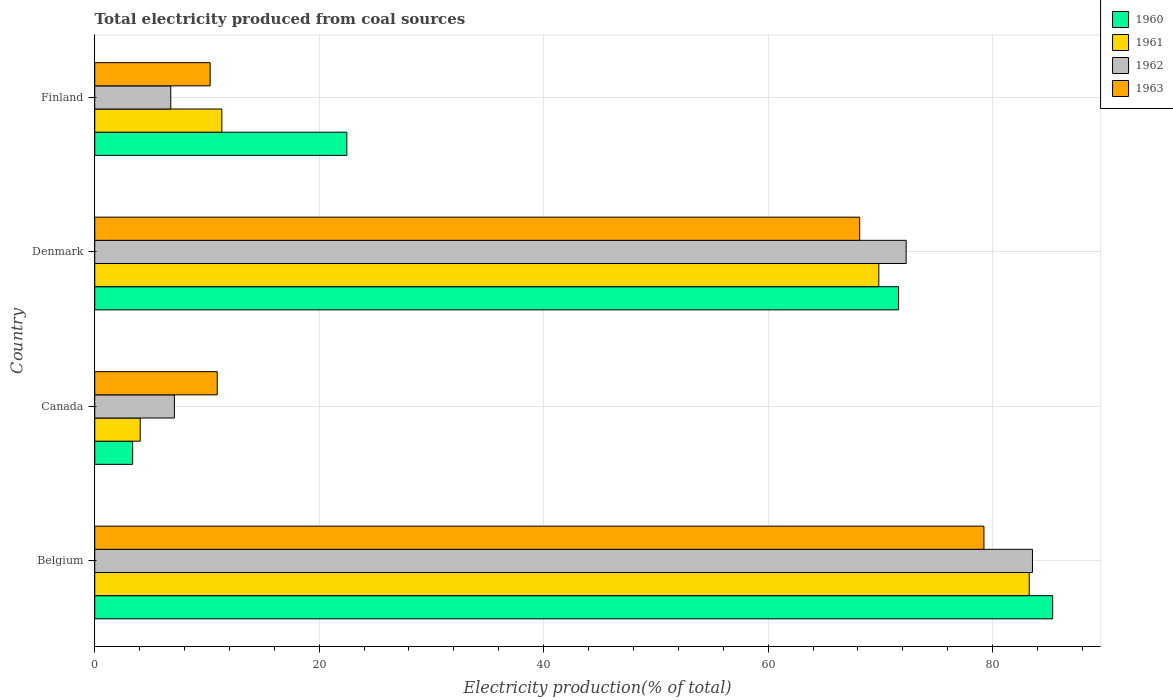How many different coloured bars are there?
Provide a short and direct response. 4. Are the number of bars per tick equal to the number of legend labels?
Make the answer very short. Yes. Are the number of bars on each tick of the Y-axis equal?
Keep it short and to the point. Yes. How many bars are there on the 4th tick from the top?
Provide a succinct answer. 4. In how many cases, is the number of bars for a given country not equal to the number of legend labels?
Give a very brief answer. 0. What is the total electricity produced in 1962 in Finland?
Provide a succinct answer. 6.78. Across all countries, what is the maximum total electricity produced in 1962?
Make the answer very short. 83.56. Across all countries, what is the minimum total electricity produced in 1963?
Provide a succinct answer. 10.28. In which country was the total electricity produced in 1962 minimum?
Your answer should be very brief. Finland. What is the total total electricity produced in 1961 in the graph?
Make the answer very short. 168.51. What is the difference between the total electricity produced in 1961 in Belgium and that in Canada?
Offer a terse response. 79.21. What is the difference between the total electricity produced in 1961 in Denmark and the total electricity produced in 1963 in Finland?
Offer a very short reply. 59.58. What is the average total electricity produced in 1963 per country?
Offer a very short reply. 42.15. What is the difference between the total electricity produced in 1961 and total electricity produced in 1960 in Belgium?
Provide a short and direct response. -2.09. What is the ratio of the total electricity produced in 1962 in Canada to that in Finland?
Provide a succinct answer. 1.05. Is the total electricity produced in 1961 in Belgium less than that in Finland?
Offer a terse response. No. Is the difference between the total electricity produced in 1961 in Belgium and Canada greater than the difference between the total electricity produced in 1960 in Belgium and Canada?
Make the answer very short. No. What is the difference between the highest and the second highest total electricity produced in 1962?
Your response must be concise. 11.26. What is the difference between the highest and the lowest total electricity produced in 1961?
Provide a succinct answer. 79.21. In how many countries, is the total electricity produced in 1960 greater than the average total electricity produced in 1960 taken over all countries?
Make the answer very short. 2. Is the sum of the total electricity produced in 1960 in Belgium and Canada greater than the maximum total electricity produced in 1961 across all countries?
Offer a terse response. Yes. Is it the case that in every country, the sum of the total electricity produced in 1962 and total electricity produced in 1960 is greater than the sum of total electricity produced in 1963 and total electricity produced in 1961?
Your response must be concise. No. What does the 3rd bar from the top in Belgium represents?
Provide a short and direct response. 1961. Are all the bars in the graph horizontal?
Your answer should be compact. Yes. How many countries are there in the graph?
Provide a short and direct response. 4. Are the values on the major ticks of X-axis written in scientific E-notation?
Provide a short and direct response. No. Does the graph contain any zero values?
Give a very brief answer. No. Does the graph contain grids?
Provide a short and direct response. Yes. Where does the legend appear in the graph?
Your answer should be very brief. Top right. How many legend labels are there?
Offer a terse response. 4. How are the legend labels stacked?
Provide a succinct answer. Vertical. What is the title of the graph?
Offer a terse response. Total electricity produced from coal sources. Does "2009" appear as one of the legend labels in the graph?
Offer a terse response. No. What is the label or title of the X-axis?
Make the answer very short. Electricity production(% of total). What is the label or title of the Y-axis?
Provide a succinct answer. Country. What is the Electricity production(% of total) in 1960 in Belgium?
Your answer should be very brief. 85.36. What is the Electricity production(% of total) in 1961 in Belgium?
Keep it short and to the point. 83.27. What is the Electricity production(% of total) of 1962 in Belgium?
Provide a succinct answer. 83.56. What is the Electricity production(% of total) of 1963 in Belgium?
Provide a short and direct response. 79.23. What is the Electricity production(% of total) of 1960 in Canada?
Offer a terse response. 3.38. What is the Electricity production(% of total) of 1961 in Canada?
Provide a short and direct response. 4.05. What is the Electricity production(% of total) of 1962 in Canada?
Provide a short and direct response. 7.1. What is the Electricity production(% of total) of 1963 in Canada?
Ensure brevity in your answer.  10.92. What is the Electricity production(% of total) in 1960 in Denmark?
Make the answer very short. 71.62. What is the Electricity production(% of total) in 1961 in Denmark?
Your answer should be compact. 69.86. What is the Electricity production(% of total) of 1962 in Denmark?
Offer a terse response. 72.3. What is the Electricity production(% of total) in 1963 in Denmark?
Keep it short and to the point. 68.16. What is the Electricity production(% of total) in 1960 in Finland?
Make the answer very short. 22.46. What is the Electricity production(% of total) in 1961 in Finland?
Your response must be concise. 11.33. What is the Electricity production(% of total) of 1962 in Finland?
Your answer should be very brief. 6.78. What is the Electricity production(% of total) in 1963 in Finland?
Provide a short and direct response. 10.28. Across all countries, what is the maximum Electricity production(% of total) of 1960?
Your answer should be compact. 85.36. Across all countries, what is the maximum Electricity production(% of total) of 1961?
Give a very brief answer. 83.27. Across all countries, what is the maximum Electricity production(% of total) of 1962?
Provide a succinct answer. 83.56. Across all countries, what is the maximum Electricity production(% of total) of 1963?
Your answer should be compact. 79.23. Across all countries, what is the minimum Electricity production(% of total) of 1960?
Your response must be concise. 3.38. Across all countries, what is the minimum Electricity production(% of total) of 1961?
Ensure brevity in your answer.  4.05. Across all countries, what is the minimum Electricity production(% of total) of 1962?
Your response must be concise. 6.78. Across all countries, what is the minimum Electricity production(% of total) of 1963?
Provide a succinct answer. 10.28. What is the total Electricity production(% of total) of 1960 in the graph?
Ensure brevity in your answer.  182.82. What is the total Electricity production(% of total) of 1961 in the graph?
Provide a short and direct response. 168.51. What is the total Electricity production(% of total) of 1962 in the graph?
Offer a terse response. 169.73. What is the total Electricity production(% of total) in 1963 in the graph?
Provide a short and direct response. 168.59. What is the difference between the Electricity production(% of total) of 1960 in Belgium and that in Canada?
Make the answer very short. 81.98. What is the difference between the Electricity production(% of total) in 1961 in Belgium and that in Canada?
Your answer should be very brief. 79.21. What is the difference between the Electricity production(% of total) in 1962 in Belgium and that in Canada?
Make the answer very short. 76.46. What is the difference between the Electricity production(% of total) of 1963 in Belgium and that in Canada?
Make the answer very short. 68.31. What is the difference between the Electricity production(% of total) in 1960 in Belgium and that in Denmark?
Your answer should be very brief. 13.73. What is the difference between the Electricity production(% of total) in 1961 in Belgium and that in Denmark?
Your answer should be very brief. 13.4. What is the difference between the Electricity production(% of total) of 1962 in Belgium and that in Denmark?
Keep it short and to the point. 11.26. What is the difference between the Electricity production(% of total) in 1963 in Belgium and that in Denmark?
Your response must be concise. 11.07. What is the difference between the Electricity production(% of total) in 1960 in Belgium and that in Finland?
Provide a succinct answer. 62.89. What is the difference between the Electricity production(% of total) of 1961 in Belgium and that in Finland?
Offer a terse response. 71.94. What is the difference between the Electricity production(% of total) of 1962 in Belgium and that in Finland?
Your response must be concise. 76.78. What is the difference between the Electricity production(% of total) in 1963 in Belgium and that in Finland?
Give a very brief answer. 68.95. What is the difference between the Electricity production(% of total) in 1960 in Canada and that in Denmark?
Ensure brevity in your answer.  -68.25. What is the difference between the Electricity production(% of total) of 1961 in Canada and that in Denmark?
Your answer should be compact. -65.81. What is the difference between the Electricity production(% of total) in 1962 in Canada and that in Denmark?
Your response must be concise. -65.2. What is the difference between the Electricity production(% of total) of 1963 in Canada and that in Denmark?
Provide a short and direct response. -57.24. What is the difference between the Electricity production(% of total) of 1960 in Canada and that in Finland?
Make the answer very short. -19.09. What is the difference between the Electricity production(% of total) of 1961 in Canada and that in Finland?
Provide a succinct answer. -7.27. What is the difference between the Electricity production(% of total) in 1962 in Canada and that in Finland?
Provide a succinct answer. 0.32. What is the difference between the Electricity production(% of total) of 1963 in Canada and that in Finland?
Offer a very short reply. 0.63. What is the difference between the Electricity production(% of total) of 1960 in Denmark and that in Finland?
Provide a succinct answer. 49.16. What is the difference between the Electricity production(% of total) of 1961 in Denmark and that in Finland?
Provide a short and direct response. 58.54. What is the difference between the Electricity production(% of total) in 1962 in Denmark and that in Finland?
Provide a short and direct response. 65.53. What is the difference between the Electricity production(% of total) of 1963 in Denmark and that in Finland?
Provide a succinct answer. 57.88. What is the difference between the Electricity production(% of total) of 1960 in Belgium and the Electricity production(% of total) of 1961 in Canada?
Provide a succinct answer. 81.3. What is the difference between the Electricity production(% of total) of 1960 in Belgium and the Electricity production(% of total) of 1962 in Canada?
Your response must be concise. 78.26. What is the difference between the Electricity production(% of total) of 1960 in Belgium and the Electricity production(% of total) of 1963 in Canada?
Ensure brevity in your answer.  74.44. What is the difference between the Electricity production(% of total) in 1961 in Belgium and the Electricity production(% of total) in 1962 in Canada?
Provide a short and direct response. 76.17. What is the difference between the Electricity production(% of total) of 1961 in Belgium and the Electricity production(% of total) of 1963 in Canada?
Provide a succinct answer. 72.35. What is the difference between the Electricity production(% of total) in 1962 in Belgium and the Electricity production(% of total) in 1963 in Canada?
Provide a short and direct response. 72.64. What is the difference between the Electricity production(% of total) in 1960 in Belgium and the Electricity production(% of total) in 1961 in Denmark?
Provide a short and direct response. 15.49. What is the difference between the Electricity production(% of total) of 1960 in Belgium and the Electricity production(% of total) of 1962 in Denmark?
Your answer should be very brief. 13.05. What is the difference between the Electricity production(% of total) in 1960 in Belgium and the Electricity production(% of total) in 1963 in Denmark?
Ensure brevity in your answer.  17.19. What is the difference between the Electricity production(% of total) in 1961 in Belgium and the Electricity production(% of total) in 1962 in Denmark?
Provide a short and direct response. 10.97. What is the difference between the Electricity production(% of total) in 1961 in Belgium and the Electricity production(% of total) in 1963 in Denmark?
Provide a short and direct response. 15.11. What is the difference between the Electricity production(% of total) of 1962 in Belgium and the Electricity production(% of total) of 1963 in Denmark?
Your answer should be compact. 15.4. What is the difference between the Electricity production(% of total) in 1960 in Belgium and the Electricity production(% of total) in 1961 in Finland?
Your response must be concise. 74.03. What is the difference between the Electricity production(% of total) of 1960 in Belgium and the Electricity production(% of total) of 1962 in Finland?
Your answer should be compact. 78.58. What is the difference between the Electricity production(% of total) of 1960 in Belgium and the Electricity production(% of total) of 1963 in Finland?
Your answer should be very brief. 75.07. What is the difference between the Electricity production(% of total) in 1961 in Belgium and the Electricity production(% of total) in 1962 in Finland?
Provide a short and direct response. 76.49. What is the difference between the Electricity production(% of total) of 1961 in Belgium and the Electricity production(% of total) of 1963 in Finland?
Ensure brevity in your answer.  72.98. What is the difference between the Electricity production(% of total) of 1962 in Belgium and the Electricity production(% of total) of 1963 in Finland?
Your answer should be very brief. 73.27. What is the difference between the Electricity production(% of total) of 1960 in Canada and the Electricity production(% of total) of 1961 in Denmark?
Provide a succinct answer. -66.49. What is the difference between the Electricity production(% of total) of 1960 in Canada and the Electricity production(% of total) of 1962 in Denmark?
Make the answer very short. -68.92. What is the difference between the Electricity production(% of total) in 1960 in Canada and the Electricity production(% of total) in 1963 in Denmark?
Ensure brevity in your answer.  -64.78. What is the difference between the Electricity production(% of total) of 1961 in Canada and the Electricity production(% of total) of 1962 in Denmark?
Give a very brief answer. -68.25. What is the difference between the Electricity production(% of total) of 1961 in Canada and the Electricity production(% of total) of 1963 in Denmark?
Offer a terse response. -64.11. What is the difference between the Electricity production(% of total) of 1962 in Canada and the Electricity production(% of total) of 1963 in Denmark?
Offer a very short reply. -61.06. What is the difference between the Electricity production(% of total) of 1960 in Canada and the Electricity production(% of total) of 1961 in Finland?
Offer a very short reply. -7.95. What is the difference between the Electricity production(% of total) in 1960 in Canada and the Electricity production(% of total) in 1962 in Finland?
Your answer should be very brief. -3.4. What is the difference between the Electricity production(% of total) of 1960 in Canada and the Electricity production(% of total) of 1963 in Finland?
Your response must be concise. -6.91. What is the difference between the Electricity production(% of total) of 1961 in Canada and the Electricity production(% of total) of 1962 in Finland?
Keep it short and to the point. -2.72. What is the difference between the Electricity production(% of total) in 1961 in Canada and the Electricity production(% of total) in 1963 in Finland?
Give a very brief answer. -6.23. What is the difference between the Electricity production(% of total) in 1962 in Canada and the Electricity production(% of total) in 1963 in Finland?
Your response must be concise. -3.18. What is the difference between the Electricity production(% of total) in 1960 in Denmark and the Electricity production(% of total) in 1961 in Finland?
Give a very brief answer. 60.3. What is the difference between the Electricity production(% of total) in 1960 in Denmark and the Electricity production(% of total) in 1962 in Finland?
Keep it short and to the point. 64.85. What is the difference between the Electricity production(% of total) of 1960 in Denmark and the Electricity production(% of total) of 1963 in Finland?
Make the answer very short. 61.34. What is the difference between the Electricity production(% of total) in 1961 in Denmark and the Electricity production(% of total) in 1962 in Finland?
Ensure brevity in your answer.  63.09. What is the difference between the Electricity production(% of total) of 1961 in Denmark and the Electricity production(% of total) of 1963 in Finland?
Provide a short and direct response. 59.58. What is the difference between the Electricity production(% of total) in 1962 in Denmark and the Electricity production(% of total) in 1963 in Finland?
Your response must be concise. 62.02. What is the average Electricity production(% of total) of 1960 per country?
Provide a succinct answer. 45.71. What is the average Electricity production(% of total) of 1961 per country?
Offer a terse response. 42.13. What is the average Electricity production(% of total) of 1962 per country?
Make the answer very short. 42.43. What is the average Electricity production(% of total) in 1963 per country?
Ensure brevity in your answer.  42.15. What is the difference between the Electricity production(% of total) in 1960 and Electricity production(% of total) in 1961 in Belgium?
Offer a terse response. 2.09. What is the difference between the Electricity production(% of total) in 1960 and Electricity production(% of total) in 1962 in Belgium?
Provide a succinct answer. 1.8. What is the difference between the Electricity production(% of total) of 1960 and Electricity production(% of total) of 1963 in Belgium?
Offer a very short reply. 6.12. What is the difference between the Electricity production(% of total) of 1961 and Electricity production(% of total) of 1962 in Belgium?
Your response must be concise. -0.29. What is the difference between the Electricity production(% of total) of 1961 and Electricity production(% of total) of 1963 in Belgium?
Give a very brief answer. 4.04. What is the difference between the Electricity production(% of total) of 1962 and Electricity production(% of total) of 1963 in Belgium?
Provide a short and direct response. 4.33. What is the difference between the Electricity production(% of total) of 1960 and Electricity production(% of total) of 1961 in Canada?
Your answer should be very brief. -0.68. What is the difference between the Electricity production(% of total) in 1960 and Electricity production(% of total) in 1962 in Canada?
Your answer should be very brief. -3.72. What is the difference between the Electricity production(% of total) in 1960 and Electricity production(% of total) in 1963 in Canada?
Give a very brief answer. -7.54. What is the difference between the Electricity production(% of total) of 1961 and Electricity production(% of total) of 1962 in Canada?
Your answer should be compact. -3.04. What is the difference between the Electricity production(% of total) of 1961 and Electricity production(% of total) of 1963 in Canada?
Your response must be concise. -6.86. What is the difference between the Electricity production(% of total) of 1962 and Electricity production(% of total) of 1963 in Canada?
Your answer should be compact. -3.82. What is the difference between the Electricity production(% of total) of 1960 and Electricity production(% of total) of 1961 in Denmark?
Keep it short and to the point. 1.76. What is the difference between the Electricity production(% of total) of 1960 and Electricity production(% of total) of 1962 in Denmark?
Make the answer very short. -0.68. What is the difference between the Electricity production(% of total) in 1960 and Electricity production(% of total) in 1963 in Denmark?
Your answer should be very brief. 3.46. What is the difference between the Electricity production(% of total) of 1961 and Electricity production(% of total) of 1962 in Denmark?
Offer a terse response. -2.44. What is the difference between the Electricity production(% of total) in 1961 and Electricity production(% of total) in 1963 in Denmark?
Keep it short and to the point. 1.7. What is the difference between the Electricity production(% of total) of 1962 and Electricity production(% of total) of 1963 in Denmark?
Provide a succinct answer. 4.14. What is the difference between the Electricity production(% of total) in 1960 and Electricity production(% of total) in 1961 in Finland?
Offer a very short reply. 11.14. What is the difference between the Electricity production(% of total) in 1960 and Electricity production(% of total) in 1962 in Finland?
Your answer should be very brief. 15.69. What is the difference between the Electricity production(% of total) in 1960 and Electricity production(% of total) in 1963 in Finland?
Your answer should be very brief. 12.18. What is the difference between the Electricity production(% of total) in 1961 and Electricity production(% of total) in 1962 in Finland?
Offer a very short reply. 4.55. What is the difference between the Electricity production(% of total) of 1961 and Electricity production(% of total) of 1963 in Finland?
Your answer should be compact. 1.04. What is the difference between the Electricity production(% of total) in 1962 and Electricity production(% of total) in 1963 in Finland?
Ensure brevity in your answer.  -3.51. What is the ratio of the Electricity production(% of total) of 1960 in Belgium to that in Canada?
Provide a succinct answer. 25.27. What is the ratio of the Electricity production(% of total) of 1961 in Belgium to that in Canada?
Give a very brief answer. 20.54. What is the ratio of the Electricity production(% of total) of 1962 in Belgium to that in Canada?
Keep it short and to the point. 11.77. What is the ratio of the Electricity production(% of total) in 1963 in Belgium to that in Canada?
Your answer should be compact. 7.26. What is the ratio of the Electricity production(% of total) of 1960 in Belgium to that in Denmark?
Provide a succinct answer. 1.19. What is the ratio of the Electricity production(% of total) in 1961 in Belgium to that in Denmark?
Ensure brevity in your answer.  1.19. What is the ratio of the Electricity production(% of total) in 1962 in Belgium to that in Denmark?
Your response must be concise. 1.16. What is the ratio of the Electricity production(% of total) in 1963 in Belgium to that in Denmark?
Keep it short and to the point. 1.16. What is the ratio of the Electricity production(% of total) in 1960 in Belgium to that in Finland?
Provide a short and direct response. 3.8. What is the ratio of the Electricity production(% of total) in 1961 in Belgium to that in Finland?
Provide a succinct answer. 7.35. What is the ratio of the Electricity production(% of total) of 1962 in Belgium to that in Finland?
Give a very brief answer. 12.33. What is the ratio of the Electricity production(% of total) in 1963 in Belgium to that in Finland?
Give a very brief answer. 7.7. What is the ratio of the Electricity production(% of total) in 1960 in Canada to that in Denmark?
Keep it short and to the point. 0.05. What is the ratio of the Electricity production(% of total) of 1961 in Canada to that in Denmark?
Offer a terse response. 0.06. What is the ratio of the Electricity production(% of total) of 1962 in Canada to that in Denmark?
Provide a succinct answer. 0.1. What is the ratio of the Electricity production(% of total) in 1963 in Canada to that in Denmark?
Make the answer very short. 0.16. What is the ratio of the Electricity production(% of total) of 1960 in Canada to that in Finland?
Provide a short and direct response. 0.15. What is the ratio of the Electricity production(% of total) of 1961 in Canada to that in Finland?
Offer a terse response. 0.36. What is the ratio of the Electricity production(% of total) in 1962 in Canada to that in Finland?
Provide a succinct answer. 1.05. What is the ratio of the Electricity production(% of total) in 1963 in Canada to that in Finland?
Provide a short and direct response. 1.06. What is the ratio of the Electricity production(% of total) of 1960 in Denmark to that in Finland?
Offer a very short reply. 3.19. What is the ratio of the Electricity production(% of total) in 1961 in Denmark to that in Finland?
Ensure brevity in your answer.  6.17. What is the ratio of the Electricity production(% of total) in 1962 in Denmark to that in Finland?
Give a very brief answer. 10.67. What is the ratio of the Electricity production(% of total) of 1963 in Denmark to that in Finland?
Provide a short and direct response. 6.63. What is the difference between the highest and the second highest Electricity production(% of total) in 1960?
Give a very brief answer. 13.73. What is the difference between the highest and the second highest Electricity production(% of total) in 1961?
Keep it short and to the point. 13.4. What is the difference between the highest and the second highest Electricity production(% of total) in 1962?
Offer a terse response. 11.26. What is the difference between the highest and the second highest Electricity production(% of total) of 1963?
Offer a very short reply. 11.07. What is the difference between the highest and the lowest Electricity production(% of total) in 1960?
Your answer should be very brief. 81.98. What is the difference between the highest and the lowest Electricity production(% of total) in 1961?
Your response must be concise. 79.21. What is the difference between the highest and the lowest Electricity production(% of total) in 1962?
Give a very brief answer. 76.78. What is the difference between the highest and the lowest Electricity production(% of total) in 1963?
Provide a succinct answer. 68.95. 